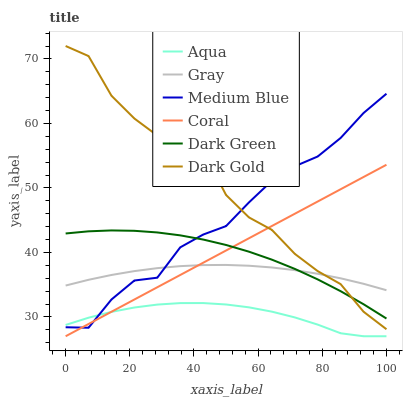Does Aqua have the minimum area under the curve?
Answer yes or no. Yes. Does Dark Gold have the maximum area under the curve?
Answer yes or no. Yes. Does Medium Blue have the minimum area under the curve?
Answer yes or no. No. Does Medium Blue have the maximum area under the curve?
Answer yes or no. No. Is Coral the smoothest?
Answer yes or no. Yes. Is Dark Gold the roughest?
Answer yes or no. Yes. Is Medium Blue the smoothest?
Answer yes or no. No. Is Medium Blue the roughest?
Answer yes or no. No. Does Coral have the lowest value?
Answer yes or no. Yes. Does Dark Gold have the lowest value?
Answer yes or no. No. Does Dark Gold have the highest value?
Answer yes or no. Yes. Does Medium Blue have the highest value?
Answer yes or no. No. Is Aqua less than Gray?
Answer yes or no. Yes. Is Dark Gold greater than Aqua?
Answer yes or no. Yes. Does Coral intersect Aqua?
Answer yes or no. Yes. Is Coral less than Aqua?
Answer yes or no. No. Is Coral greater than Aqua?
Answer yes or no. No. Does Aqua intersect Gray?
Answer yes or no. No. 